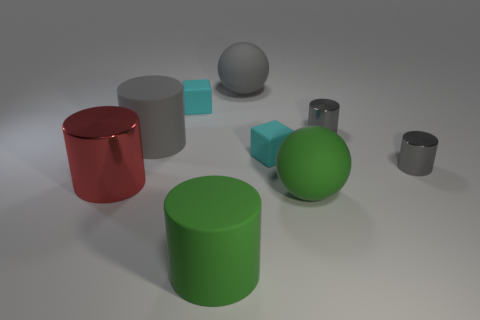There is a green ball; is it the same size as the cyan block behind the gray rubber cylinder?
Ensure brevity in your answer.  No. Does the big green cylinder have the same material as the large gray cylinder?
Offer a very short reply. Yes. There is a big gray rubber thing that is on the right side of the green matte cylinder; is its shape the same as the big object that is on the right side of the large gray ball?
Your answer should be very brief. Yes. There is another ball that is the same material as the large green sphere; what color is it?
Offer a terse response. Gray. There is a matte object that is in front of the big green matte sphere; is its size the same as the red thing that is on the left side of the big gray ball?
Offer a very short reply. Yes. The matte object that is left of the green rubber ball and in front of the big metal object has what shape?
Your answer should be compact. Cylinder. Is there a tiny yellow cube that has the same material as the green cylinder?
Offer a very short reply. No. Is the material of the large ball to the left of the green ball the same as the cylinder that is left of the gray rubber cylinder?
Your answer should be very brief. No. Are there more red rubber objects than big gray spheres?
Ensure brevity in your answer.  No. What color is the tiny metallic cylinder that is behind the big gray cylinder that is in front of the large rubber sphere that is behind the large red metallic thing?
Make the answer very short. Gray. 